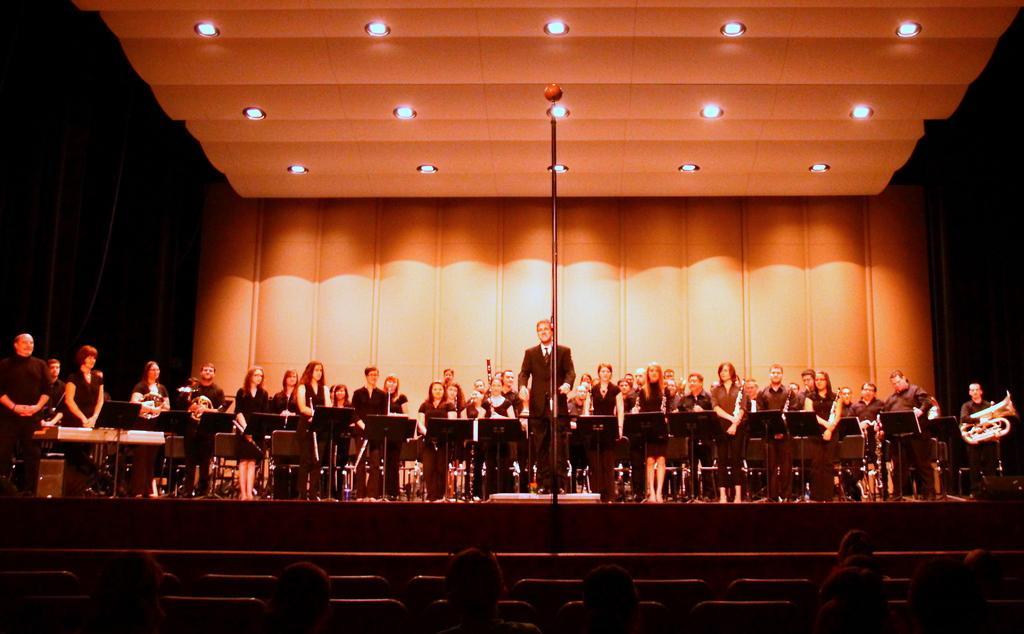Please provide a concise description of this image. In this image we can see a group of people standing on the stage and they are holding the musical instruments in their hands. Here we can see a man standing in the center. He is wearing a suit and a tie. Here we can see the pole on the stage. Here we can see the lighting arrangement on the roof. Here we can see a few people sitting on the chairs. 